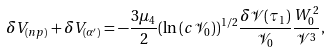<formula> <loc_0><loc_0><loc_500><loc_500>\delta V _ { ( n p ) } + \delta V _ { ( \alpha ^ { \prime } ) } = - \frac { 3 \mu _ { 4 } } { 2 } ( \ln \left ( c \mathcal { V } _ { 0 } \right ) ) ^ { 1 / 2 } \frac { \delta \mathcal { V } ( \tau _ { 1 } ) } { \mathcal { V } _ { 0 } } \frac { W _ { 0 } ^ { 2 } } { \mathcal { V } ^ { 3 } } ,</formula> 